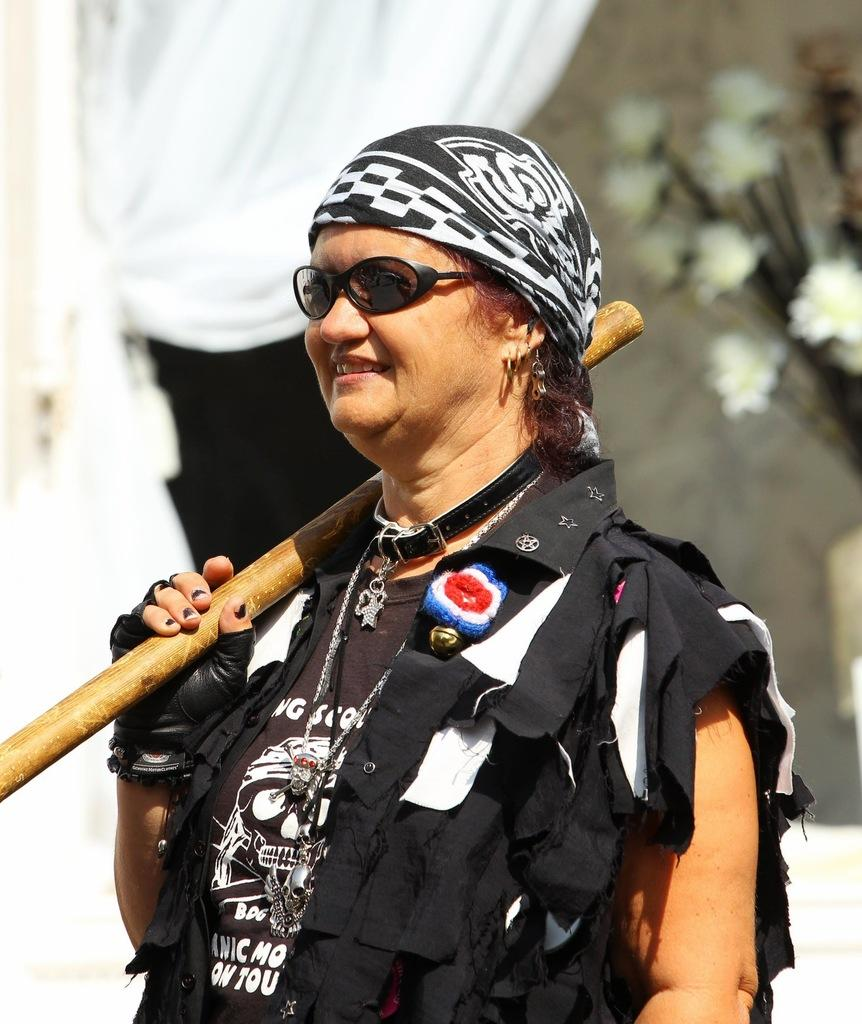Where was the image taken? The image is taken outdoors. What can be seen in the background of the image? There is a flower vase and a curtain in the background of the image. Who is the main subject in the image? There is a woman in the middle of the image. What is the woman holding in her hand? The woman is holding a stick in her hand. How many boats are visible in the image? There are no boats present in the image. What is the size of the woman's dad in the image? The image does not show the woman's dad, so it is not possible to determine his size. 